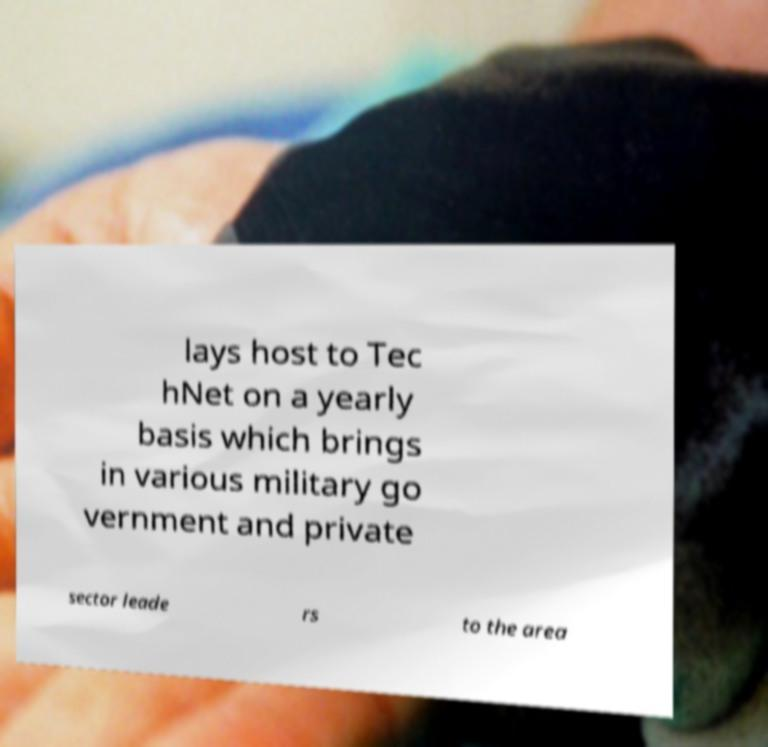There's text embedded in this image that I need extracted. Can you transcribe it verbatim? lays host to Tec hNet on a yearly basis which brings in various military go vernment and private sector leade rs to the area 